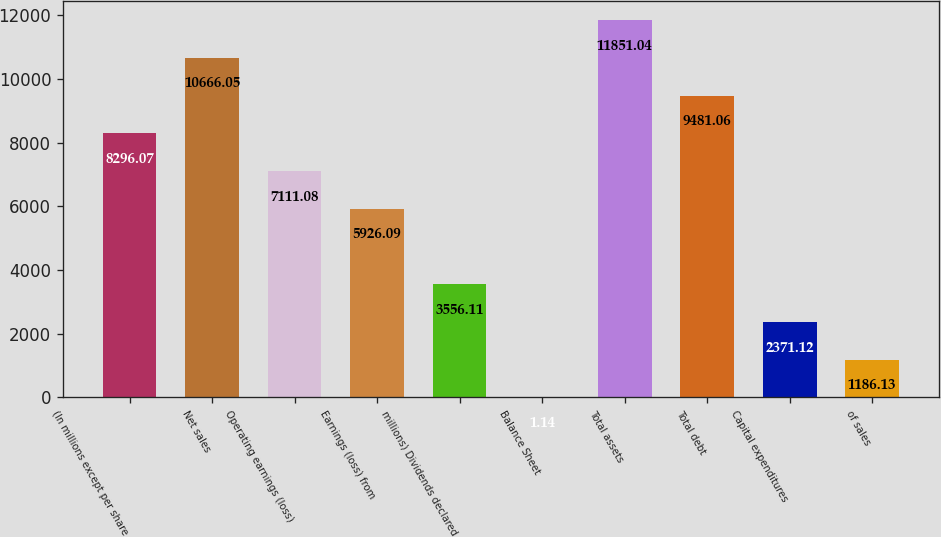Convert chart. <chart><loc_0><loc_0><loc_500><loc_500><bar_chart><fcel>(In millions except per share<fcel>Net sales<fcel>Operating earnings (loss)<fcel>Earnings (loss) from<fcel>millions) Dividends declared<fcel>Balance Sheet<fcel>Total assets<fcel>Total debt<fcel>Capital expenditures<fcel>of sales<nl><fcel>8296.07<fcel>10666<fcel>7111.08<fcel>5926.09<fcel>3556.11<fcel>1.14<fcel>11851<fcel>9481.06<fcel>2371.12<fcel>1186.13<nl></chart> 